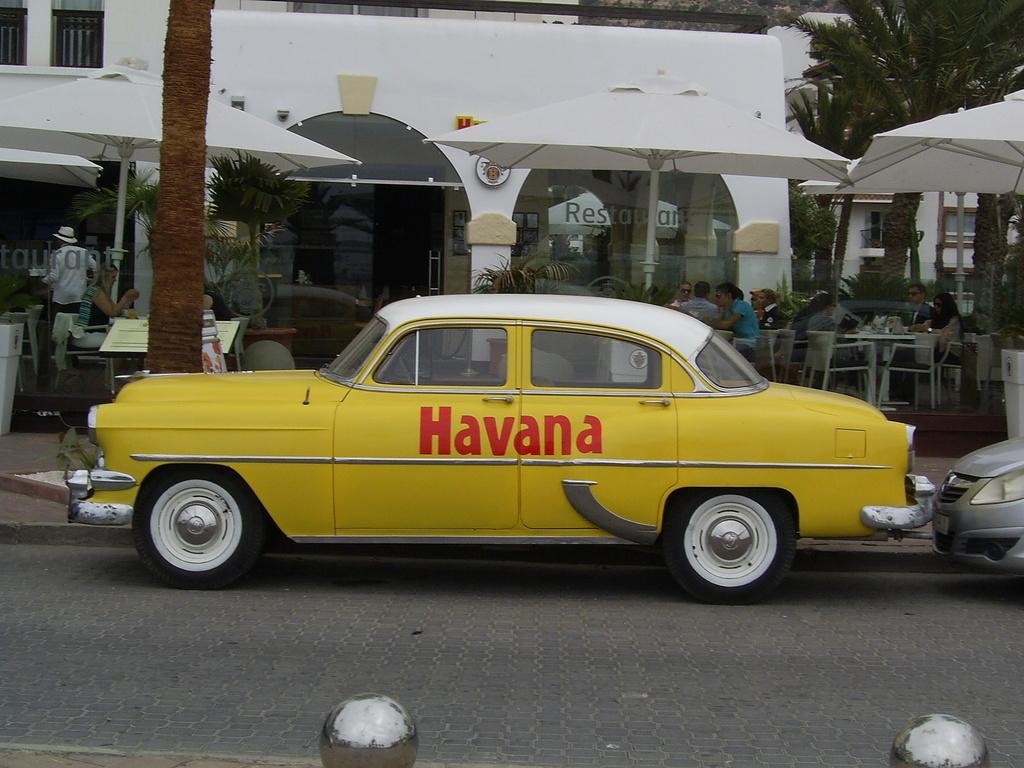<image>
Give a short and clear explanation of the subsequent image. An old yellow car that says Havana in red letters is parked on a street. 